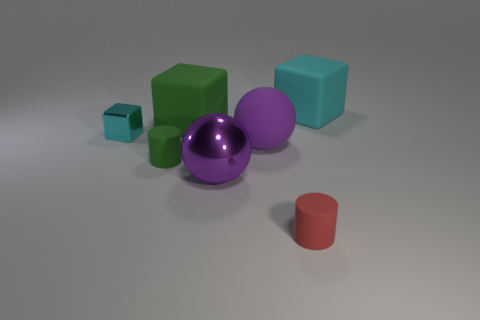Subtract all purple spheres. How many were subtracted if there are1purple spheres left? 1 Add 3 tiny purple rubber objects. How many objects exist? 10 Subtract all balls. How many objects are left? 5 Subtract 1 green cubes. How many objects are left? 6 Subtract all tiny blue cubes. Subtract all purple matte objects. How many objects are left? 6 Add 1 big rubber blocks. How many big rubber blocks are left? 3 Add 7 large cyan metal blocks. How many large cyan metal blocks exist? 7 